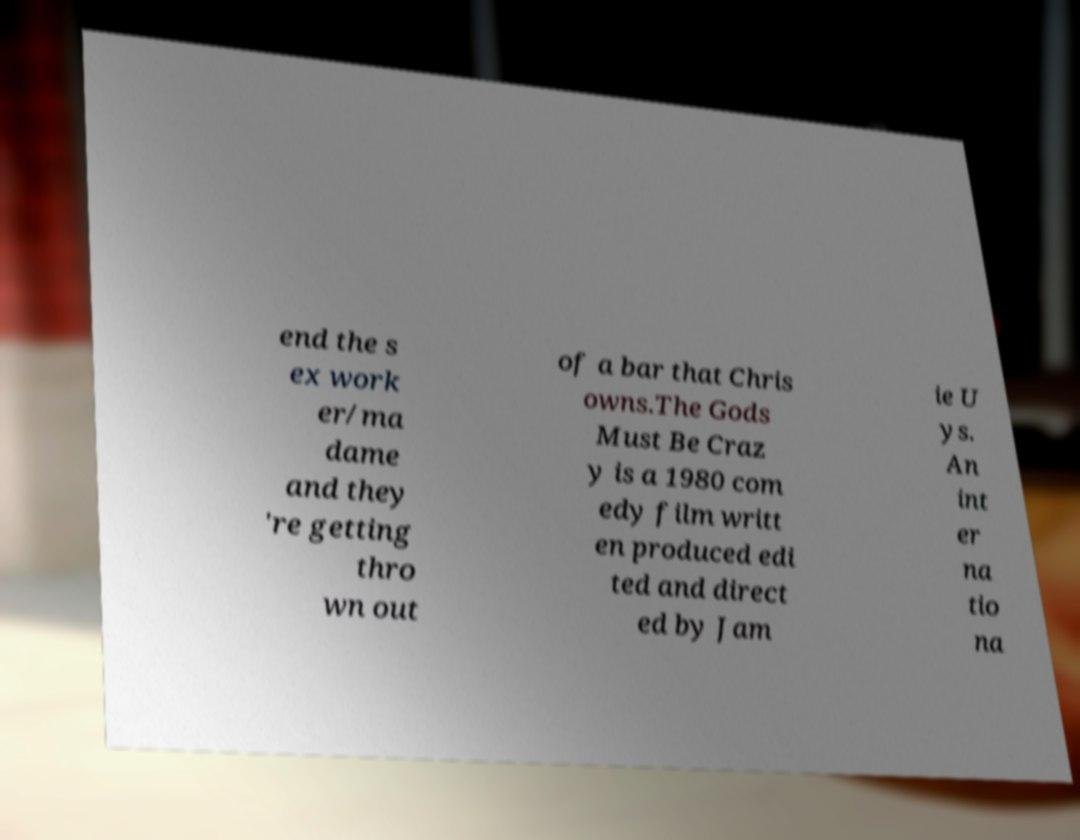Could you assist in decoding the text presented in this image and type it out clearly? end the s ex work er/ma dame and they 're getting thro wn out of a bar that Chris owns.The Gods Must Be Craz y is a 1980 com edy film writt en produced edi ted and direct ed by Jam ie U ys. An int er na tio na 